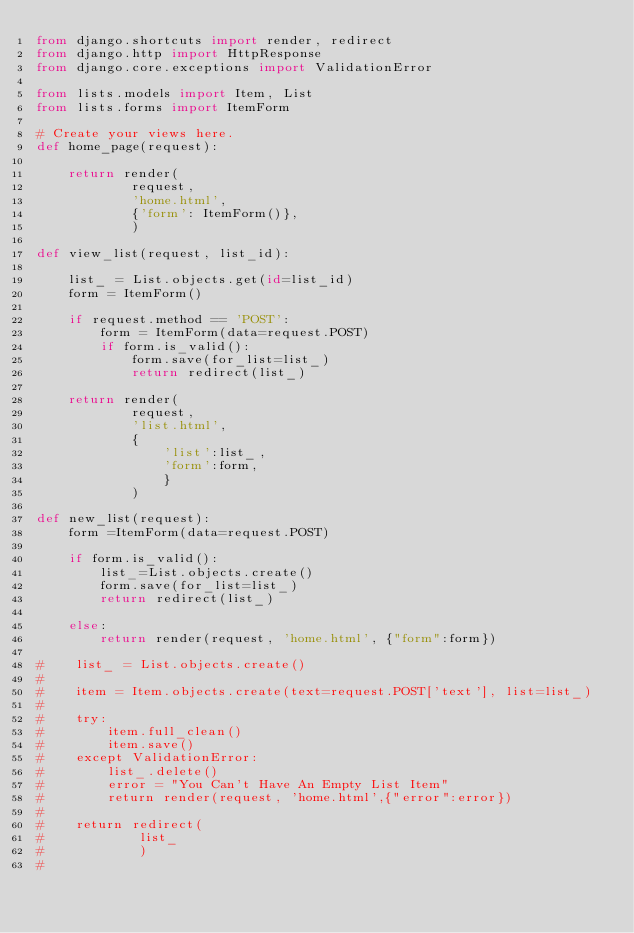Convert code to text. <code><loc_0><loc_0><loc_500><loc_500><_Python_>from django.shortcuts import render, redirect
from django.http import HttpResponse
from django.core.exceptions import ValidationError

from lists.models import Item, List
from lists.forms import ItemForm

# Create your views here.
def home_page(request): 

    return render(
            request,
            'home.html',
            {'form': ItemForm()},
            )

def view_list(request, list_id):

    list_ = List.objects.get(id=list_id)
    form = ItemForm()

    if request.method == 'POST':
        form = ItemForm(data=request.POST)
        if form.is_valid():
            form.save(for_list=list_)
            return redirect(list_)
        
    return render(
            request,
            'list.html',
            {
                'list':list_,
                'form':form,
                }
            )
                
def new_list(request):
    form =ItemForm(data=request.POST)

    if form.is_valid():
        list_=List.objects.create()
        form.save(for_list=list_)
        return redirect(list_)

    else:
        return render(request, 'home.html', {"form":form})

#    list_ = List.objects.create()
#    
#    item = Item.objects.create(text=request.POST['text'], list=list_)
#
#    try:
#        item.full_clean()
#        item.save()
#    except ValidationError:
#        list_.delete()
#        error = "You Can't Have An Empty List Item"
#        return render(request, 'home.html',{"error":error})
#                
#    return redirect(
#            list_
#            )
#
</code> 